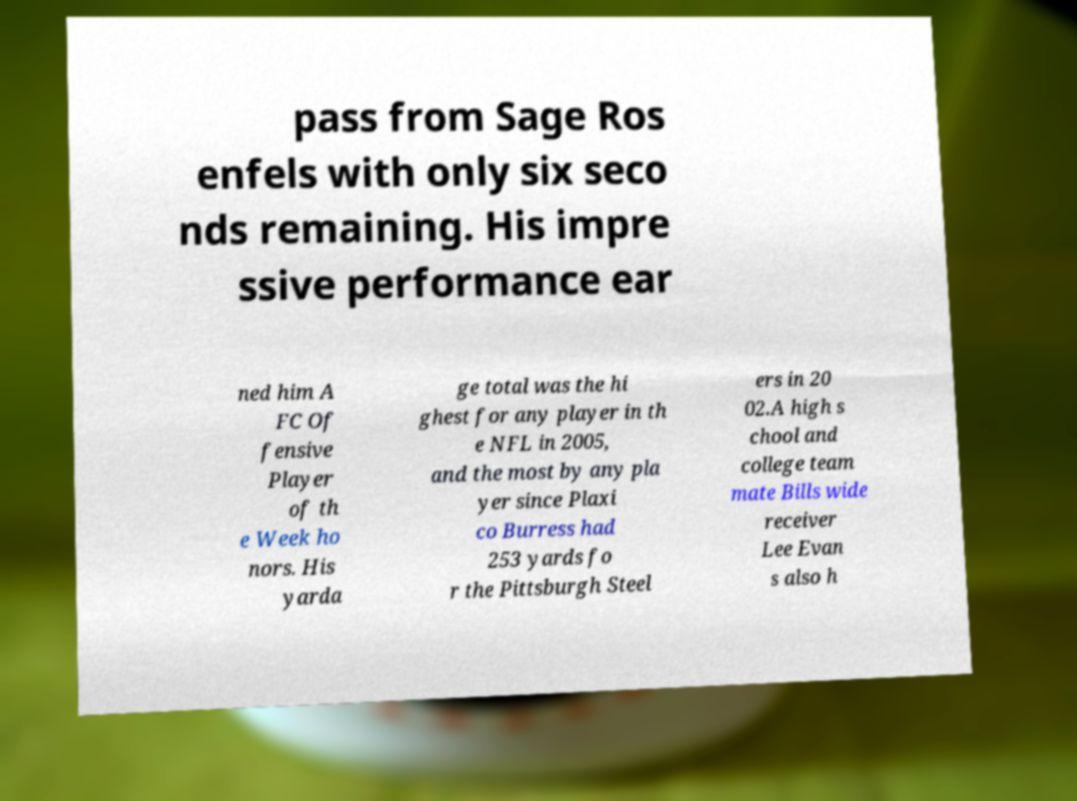For documentation purposes, I need the text within this image transcribed. Could you provide that? pass from Sage Ros enfels with only six seco nds remaining. His impre ssive performance ear ned him A FC Of fensive Player of th e Week ho nors. His yarda ge total was the hi ghest for any player in th e NFL in 2005, and the most by any pla yer since Plaxi co Burress had 253 yards fo r the Pittsburgh Steel ers in 20 02.A high s chool and college team mate Bills wide receiver Lee Evan s also h 